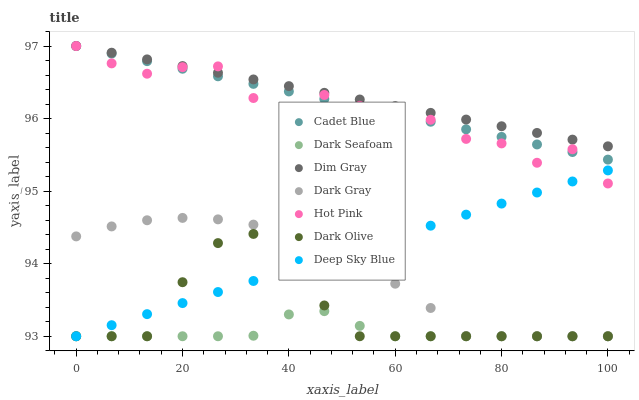Does Dark Seafoam have the minimum area under the curve?
Answer yes or no. Yes. Does Dim Gray have the maximum area under the curve?
Answer yes or no. Yes. Does Dark Olive have the minimum area under the curve?
Answer yes or no. No. Does Dark Olive have the maximum area under the curve?
Answer yes or no. No. Is Cadet Blue the smoothest?
Answer yes or no. Yes. Is Hot Pink the roughest?
Answer yes or no. Yes. Is Dark Olive the smoothest?
Answer yes or no. No. Is Dark Olive the roughest?
Answer yes or no. No. Does Dark Olive have the lowest value?
Answer yes or no. Yes. Does Dim Gray have the lowest value?
Answer yes or no. No. Does Hot Pink have the highest value?
Answer yes or no. Yes. Does Dark Olive have the highest value?
Answer yes or no. No. Is Dark Gray less than Dim Gray?
Answer yes or no. Yes. Is Hot Pink greater than Dark Olive?
Answer yes or no. Yes. Does Dim Gray intersect Cadet Blue?
Answer yes or no. Yes. Is Dim Gray less than Cadet Blue?
Answer yes or no. No. Is Dim Gray greater than Cadet Blue?
Answer yes or no. No. Does Dark Gray intersect Dim Gray?
Answer yes or no. No. 